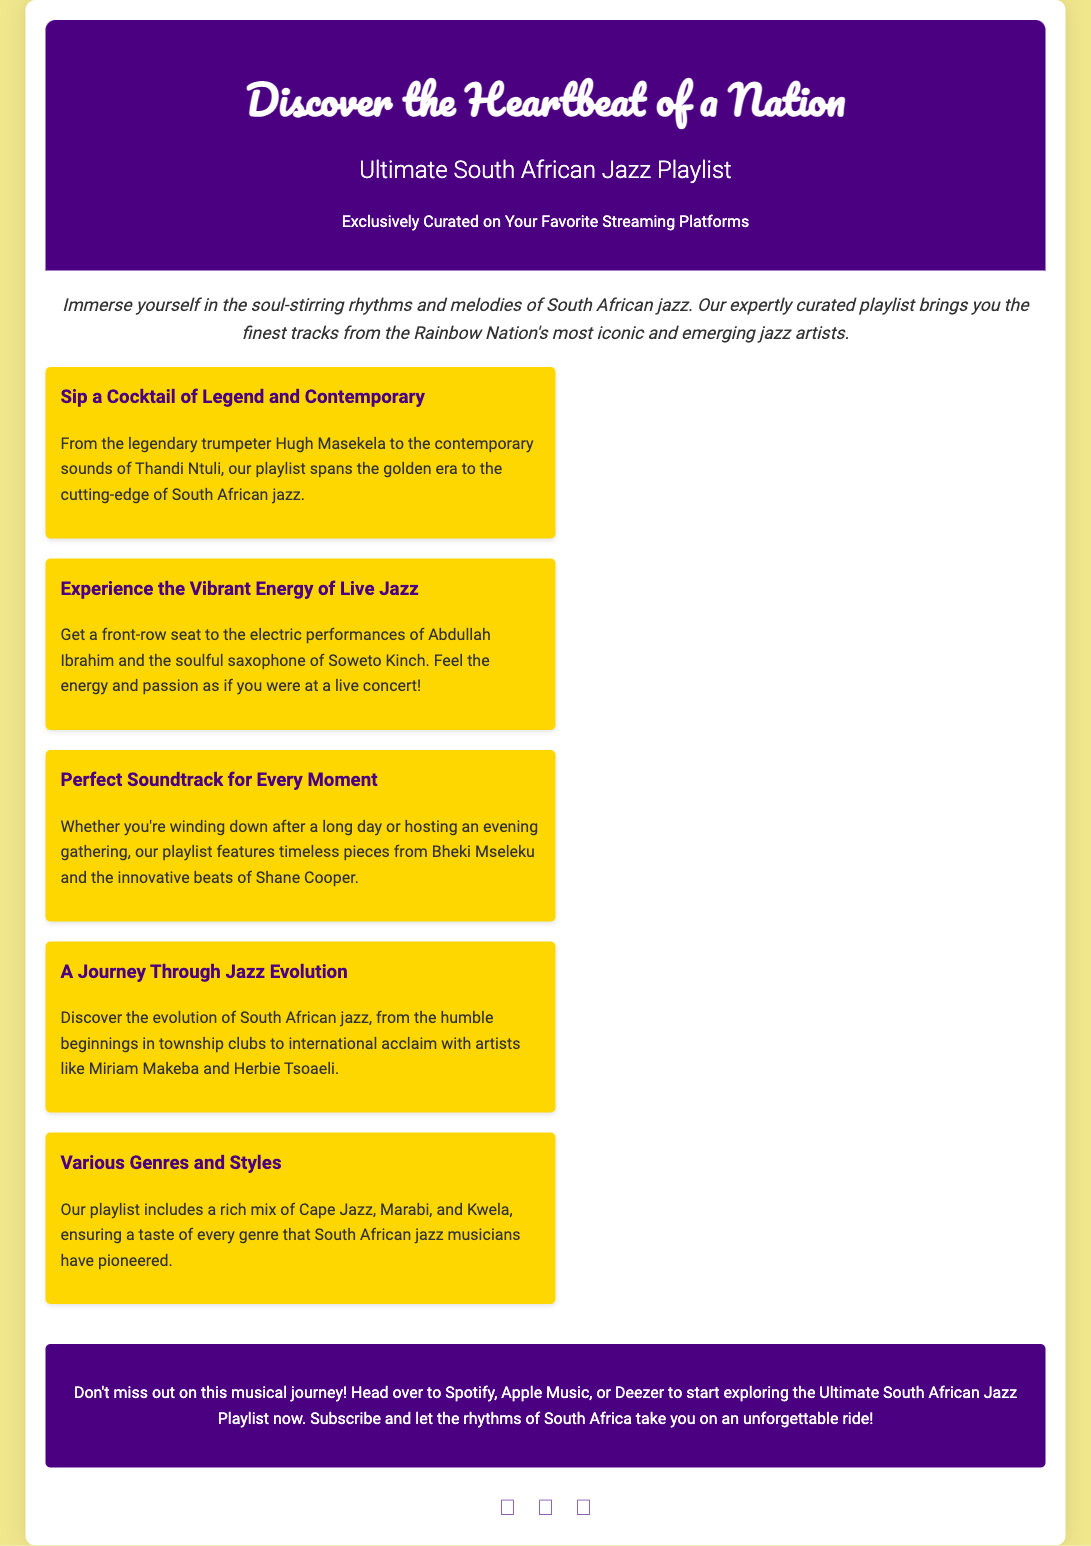What is the title of the playlist? The title of the playlist is prominently displayed in the document's header.
Answer: Ultimate South African Jazz Playlist Who is mentioned as a legendary trumpeter? The document highlights a legendary trumpeter as part of its description of artists within the playlist.
Answer: Hugh Masekela Which streaming platforms feature the playlist? The document suggests where the playlist can be found for listeners to start exploring it.
Answer: Spotify, Apple Music, Deezer What genre includes both Cape Jazz and Marabi? The document lists different genres and styles included in the playlist.
Answer: South African jazz What type of energy is associated with Abdullah Ibrahim's performance? The document describes a specific experience related to the performance of Abdullah Ibrahim.
Answer: Vibrant energy How many highlights are there in total? The number of highlights presented within the document can be counted from the content.
Answer: Five What is the introductory phrase used in the advertisement? The introduction sets the tone for the advertisement and highlights the playlist's significance.
Answer: Immerse yourself in the soul-stirring rhythms and melodies of South African jazz What moment is the soundtrack perfect for? The document identifies different moments when the playlist can be enjoyed.
Answer: Every moment 